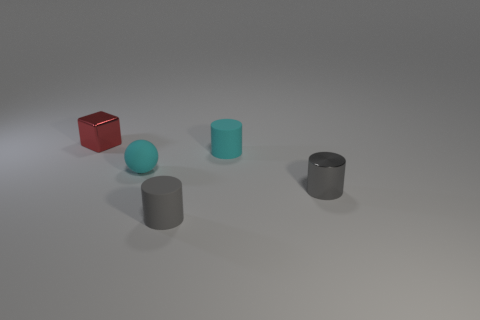Subtract all tiny gray cylinders. How many cylinders are left? 1 Add 1 gray matte objects. How many objects exist? 6 Subtract all gray cylinders. How many cylinders are left? 1 Subtract all cylinders. How many objects are left? 2 Subtract all blue cylinders. Subtract all blue balls. How many cylinders are left? 3 Subtract all green cubes. How many gray spheres are left? 0 Add 1 small cyan matte cylinders. How many small cyan matte cylinders are left? 2 Add 4 tiny cyan rubber objects. How many tiny cyan rubber objects exist? 6 Subtract 0 blue cylinders. How many objects are left? 5 Subtract all blue balls. Subtract all small red objects. How many objects are left? 4 